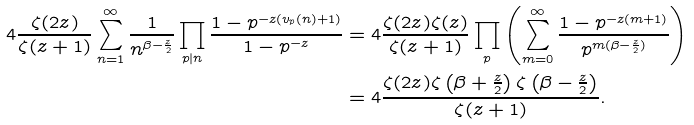Convert formula to latex. <formula><loc_0><loc_0><loc_500><loc_500>4 \frac { \zeta ( 2 z ) } { \zeta ( z + 1 ) } \sum _ { n = 1 } ^ { \infty } \frac { 1 } { n ^ { \beta - \frac { z } { 2 } } } \prod _ { p | n } \frac { 1 - p ^ { - z ( v _ { p } ( n ) + 1 ) } } { 1 - p ^ { - z } } & = 4 \frac { \zeta ( 2 z ) \zeta ( z ) } { \zeta ( z + 1 ) } \prod _ { p } \left ( \sum _ { m = 0 } ^ { \infty } \frac { 1 - p ^ { - z ( m + 1 ) } } { p ^ { m ( \beta - \frac { z } { 2 } ) } } \right ) \\ & = 4 \frac { \zeta ( 2 z ) \zeta \left ( \beta + \frac { z } { 2 } \right ) \zeta \left ( \beta - \frac { z } { 2 } \right ) } { \zeta ( z + 1 ) } .</formula> 